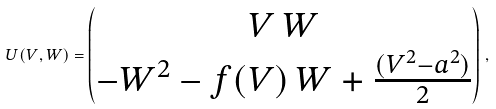Convert formula to latex. <formula><loc_0><loc_0><loc_500><loc_500>U ( V , W ) = \begin{pmatrix} V \, W \\ - W ^ { 2 } - f ( V ) \, W + \frac { ( V ^ { 2 } - a ^ { 2 } ) } { 2 } \end{pmatrix} \, ,</formula> 